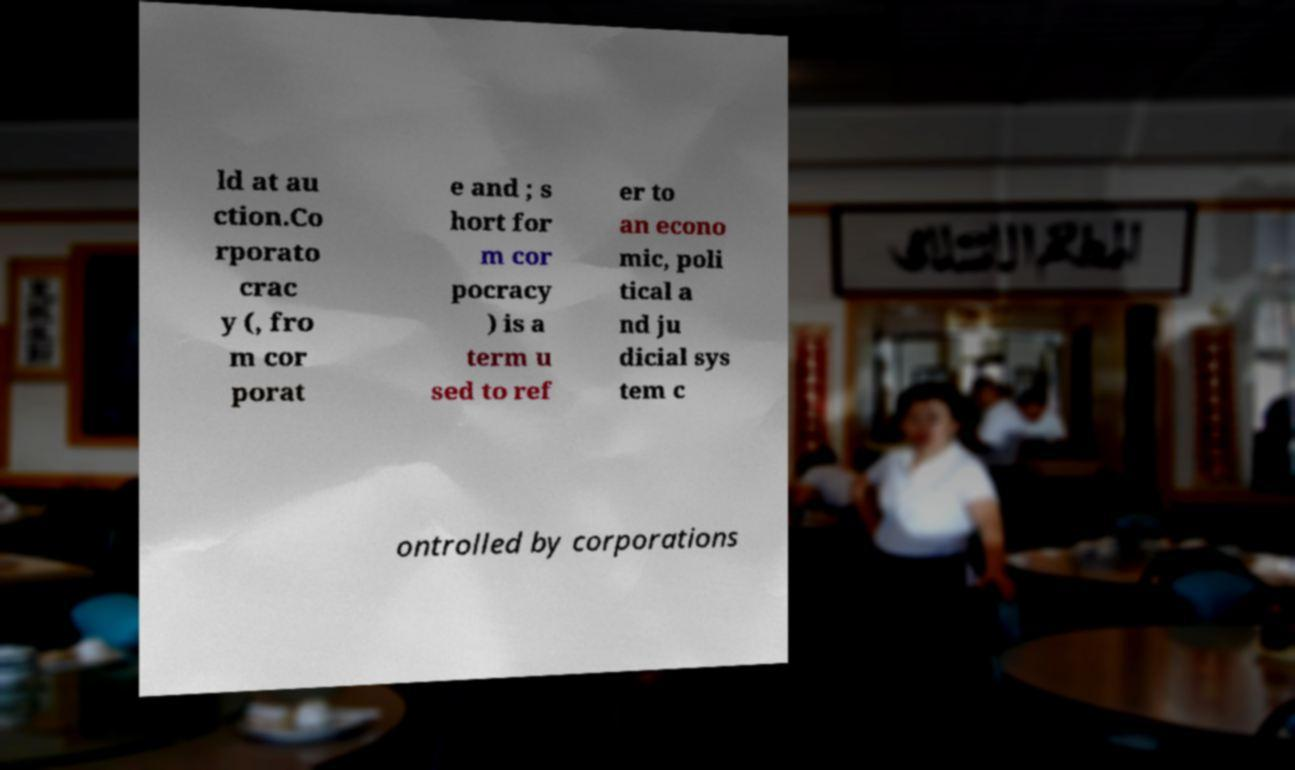Can you read and provide the text displayed in the image?This photo seems to have some interesting text. Can you extract and type it out for me? ld at au ction.Co rporato crac y (, fro m cor porat e and ; s hort for m cor pocracy ) is a term u sed to ref er to an econo mic, poli tical a nd ju dicial sys tem c ontrolled by corporations 